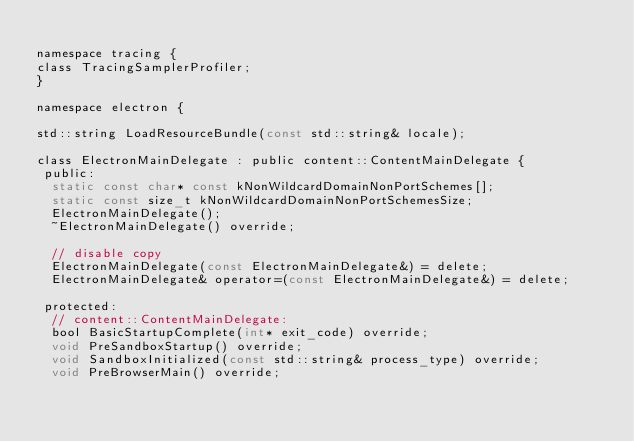<code> <loc_0><loc_0><loc_500><loc_500><_C_>
namespace tracing {
class TracingSamplerProfiler;
}

namespace electron {

std::string LoadResourceBundle(const std::string& locale);

class ElectronMainDelegate : public content::ContentMainDelegate {
 public:
  static const char* const kNonWildcardDomainNonPortSchemes[];
  static const size_t kNonWildcardDomainNonPortSchemesSize;
  ElectronMainDelegate();
  ~ElectronMainDelegate() override;

  // disable copy
  ElectronMainDelegate(const ElectronMainDelegate&) = delete;
  ElectronMainDelegate& operator=(const ElectronMainDelegate&) = delete;

 protected:
  // content::ContentMainDelegate:
  bool BasicStartupComplete(int* exit_code) override;
  void PreSandboxStartup() override;
  void SandboxInitialized(const std::string& process_type) override;
  void PreBrowserMain() override;</code> 